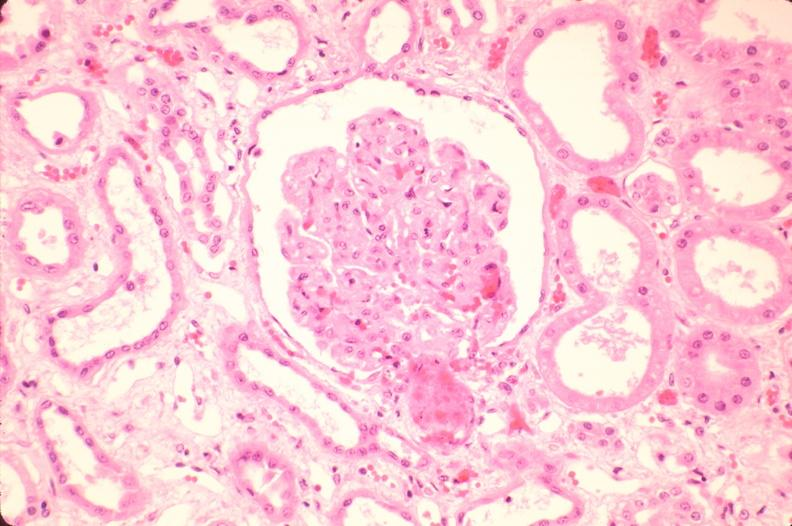does this image show kidney, microthrombi, thrombotic thrombocytopenic purpura?
Answer the question using a single word or phrase. Yes 